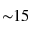<formula> <loc_0><loc_0><loc_500><loc_500>{ \sim } 1 5</formula> 